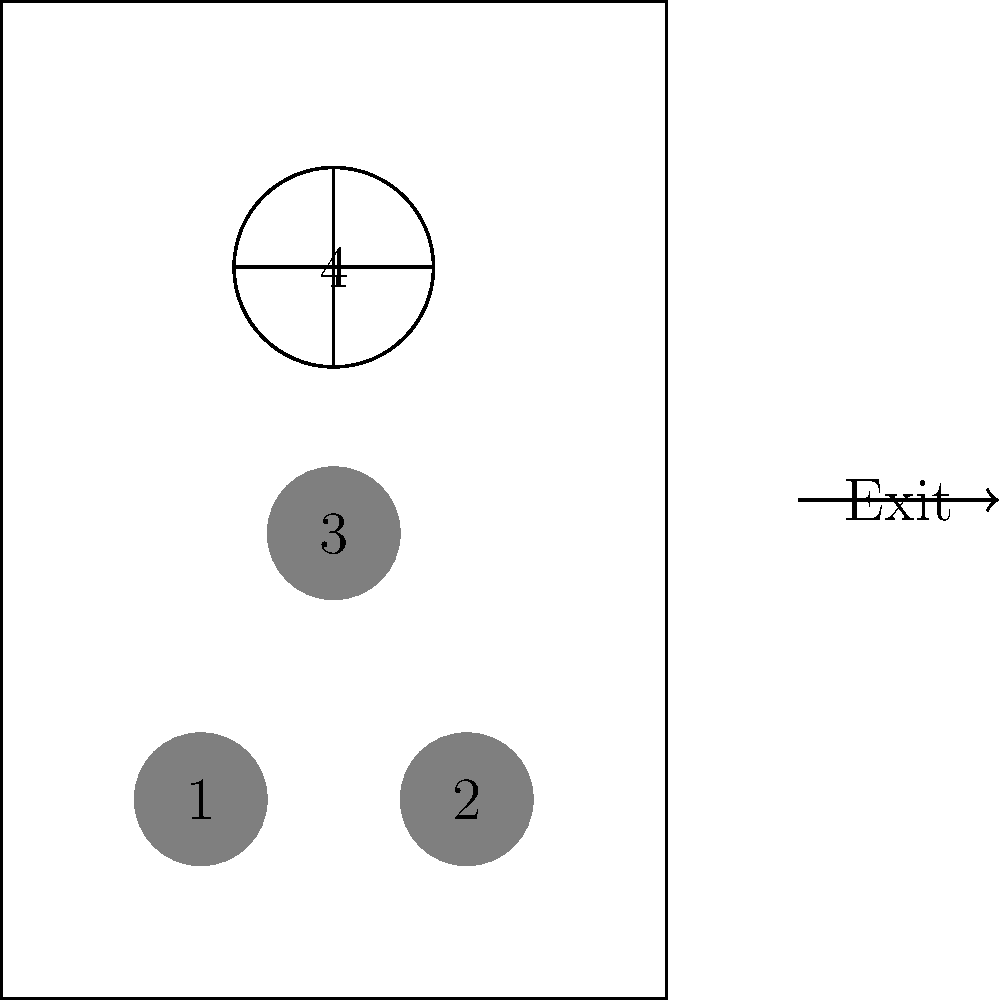In an elevator with limited space, a person using a wheelchair (labeled 4) is positioned near the back. Three able-bodied individuals (labeled 1, 2, and 3) are also present. What is the most appropriate order for exiting the elevator to ensure smooth and respectful movement for all passengers? To determine the most appropriate order for exiting the elevator, we need to consider the following factors:

1. Mobility: The person using a wheelchair (4) has limited mobility and requires more space to maneuver.
2. Position: The wheelchair user is positioned at the back of the elevator.
3. Efficiency: The exit should be organized to minimize disruption and maximize smooth movement.
4. Respect: The order should demonstrate consideration for all passengers, especially those with mobility challenges.

Given these factors, the most appropriate exit order would be:

Step 1: Individuals 1 and 2 should exit first, as they are closest to the door and can easily step out without obstructing others.

Step 2: Individual 3 should exit next, creating a clear path for the wheelchair user.

Step 3: The wheelchair user (4) should exit last, as this allows them to have a clear, unobstructed path to the door without having to navigate around other passengers.

This order ensures that:
a) The wheelchair user doesn't have to struggle to move around other passengers in the confined space.
b) Other passengers demonstrate consideration by clearing the way.
c) The exit process is efficient and minimizes the time the elevator door needs to remain open.

By following this order, all passengers show proper elevator etiquette, particularly in accommodating those with mobility devices.
Answer: 1, 2, 3, 4 (wheelchair user last) 